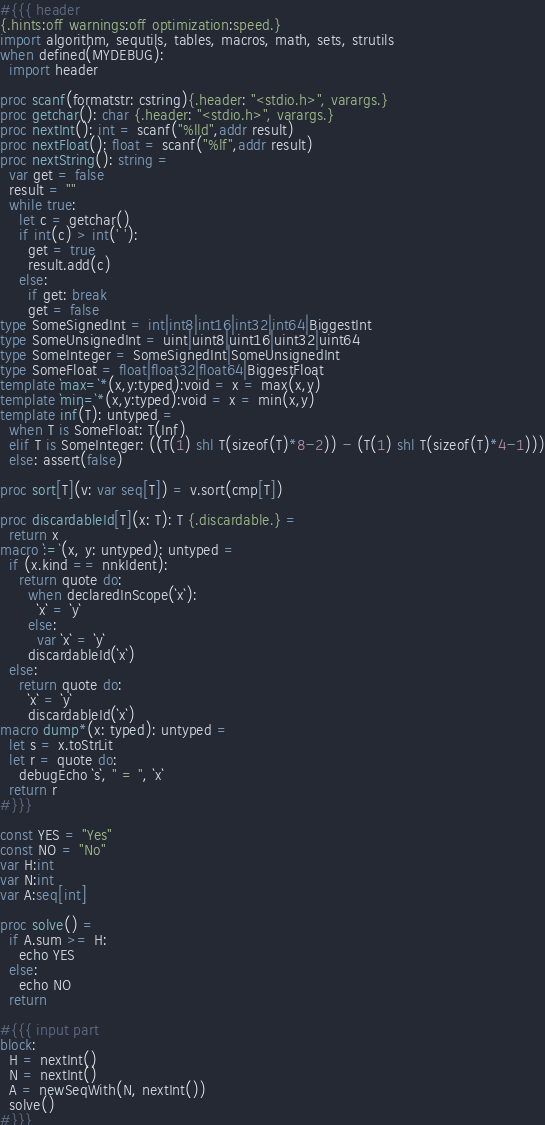Convert code to text. <code><loc_0><loc_0><loc_500><loc_500><_Nim_>#{{{ header
{.hints:off warnings:off optimization:speed.}
import algorithm, sequtils, tables, macros, math, sets, strutils
when defined(MYDEBUG):
  import header

proc scanf(formatstr: cstring){.header: "<stdio.h>", varargs.}
proc getchar(): char {.header: "<stdio.h>", varargs.}
proc nextInt(): int = scanf("%lld",addr result)
proc nextFloat(): float = scanf("%lf",addr result)
proc nextString(): string =
  var get = false
  result = ""
  while true:
    let c = getchar()
    if int(c) > int(' '):
      get = true
      result.add(c)
    else:
      if get: break
      get = false
type SomeSignedInt = int|int8|int16|int32|int64|BiggestInt
type SomeUnsignedInt = uint|uint8|uint16|uint32|uint64
type SomeInteger = SomeSignedInt|SomeUnsignedInt
type SomeFloat = float|float32|float64|BiggestFloat
template `max=`*(x,y:typed):void = x = max(x,y)
template `min=`*(x,y:typed):void = x = min(x,y)
template inf(T): untyped = 
  when T is SomeFloat: T(Inf)
  elif T is SomeInteger: ((T(1) shl T(sizeof(T)*8-2)) - (T(1) shl T(sizeof(T)*4-1)))
  else: assert(false)

proc sort[T](v: var seq[T]) = v.sort(cmp[T])

proc discardableId[T](x: T): T {.discardable.} =
  return x
macro `:=`(x, y: untyped): untyped =
  if (x.kind == nnkIdent):
    return quote do:
      when declaredInScope(`x`):
        `x` = `y`
      else:
        var `x` = `y`
      discardableId(`x`)
  else:
    return quote do:
      `x` = `y`
      discardableId(`x`)
macro dump*(x: typed): untyped =
  let s = x.toStrLit
  let r = quote do:
    debugEcho `s`, " = ", `x`
  return r
#}}}

const YES = "Yes"
const NO = "No"
var H:int
var N:int
var A:seq[int]

proc solve() =
  if A.sum >= H:
    echo YES
  else:
    echo NO
  return

#{{{ input part
block:
  H = nextInt()
  N = nextInt()
  A = newSeqWith(N, nextInt())
  solve()
#}}}
</code> 